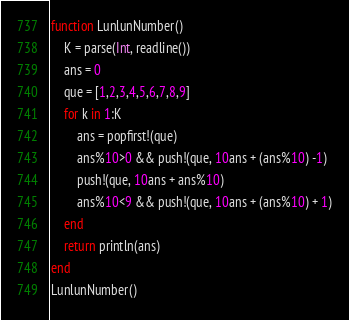<code> <loc_0><loc_0><loc_500><loc_500><_Julia_>function LunlunNumber()
    K = parse(Int, readline())
    ans = 0
    que = [1,2,3,4,5,6,7,8,9]
    for k in 1:K
        ans = popfirst!(que)
        ans%10>0 && push!(que, 10ans + (ans%10) -1)
        push!(que, 10ans + ans%10)
        ans%10<9 && push!(que, 10ans + (ans%10) + 1)
    end
    return println(ans)
end
LunlunNumber()</code> 